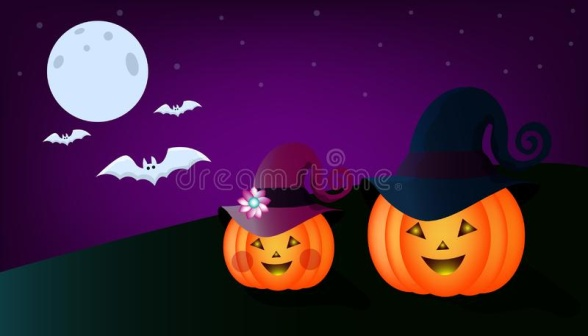 In the image, two charming jack-o-lanterns are set under a captivating night sky, illuminated by a full moon and dotted with sparkling stars. They sit on a green hill, wearing hats that add personality: the left jack-o-lantern has a purple hat with a flower, and the right one wears a black witch's hat with a purple band. Above them, three bats fly, enhancing the Halloween vibe. Imagine the two jack-o-lanterns decide to go trick-or-treating. Describe their adventure. On a magical Halloween night, the two jack-o-lanterns decided to embark on a trick-or-treating adventure. With a glow in their eyes and a bounce in their steps, they rolled down the green hill, their hats wobbling with each movement. As they entered a nearby village, the townsfolk were astonished to see the animated pumpkins. Children dressed as ghosts and witches cheered, joining the jack-o-lanterns on their quest for candy. The duo visited houses with decorated porches, collecting treats in pumpkin-shaped buckets. They even performed a few tricks, such as lighting up with different colors and telling spooky tales that made everyone shiver with delight. By the end of the night, their buckets were filled to the brim, and they rolled back up the hill, content and glowing brightly, having had the most splendid Halloween adventure. Can the bats in the image play a significant role in a Halloween story? Create a brief plot involving them. Certainly! In a thrilling Halloween story, the three bats in the image are magical guardians of the night. Each bat has a unique power: the smallest bat can turn invisible and spy on any mischief, the medium-sized bat can communicate with all nocturnal creatures, and the largest bat can manipulate the moonlight to create dazzling displays. On Halloween night, they discover a mischievous spirit intent on stealing the jack-o-lanterns' glow to plunge the village into darkness. The bats team up, using their powers to thwart the spirit's plan. With their combined efforts, they create illusions of fierce creatures to scare the spirit away. They then gather the villagers and orchestrate an enchanting moonlight performance, using their powers to project the adventures of past Halloweens in the stars above. The story celebrates teamwork, courage, and the magic of Halloween nights. 